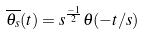Convert formula to latex. <formula><loc_0><loc_0><loc_500><loc_500>\overline { \theta _ { s } } ( t ) = s ^ { \frac { - 1 } { 2 } } \theta ( - t / s )</formula> 